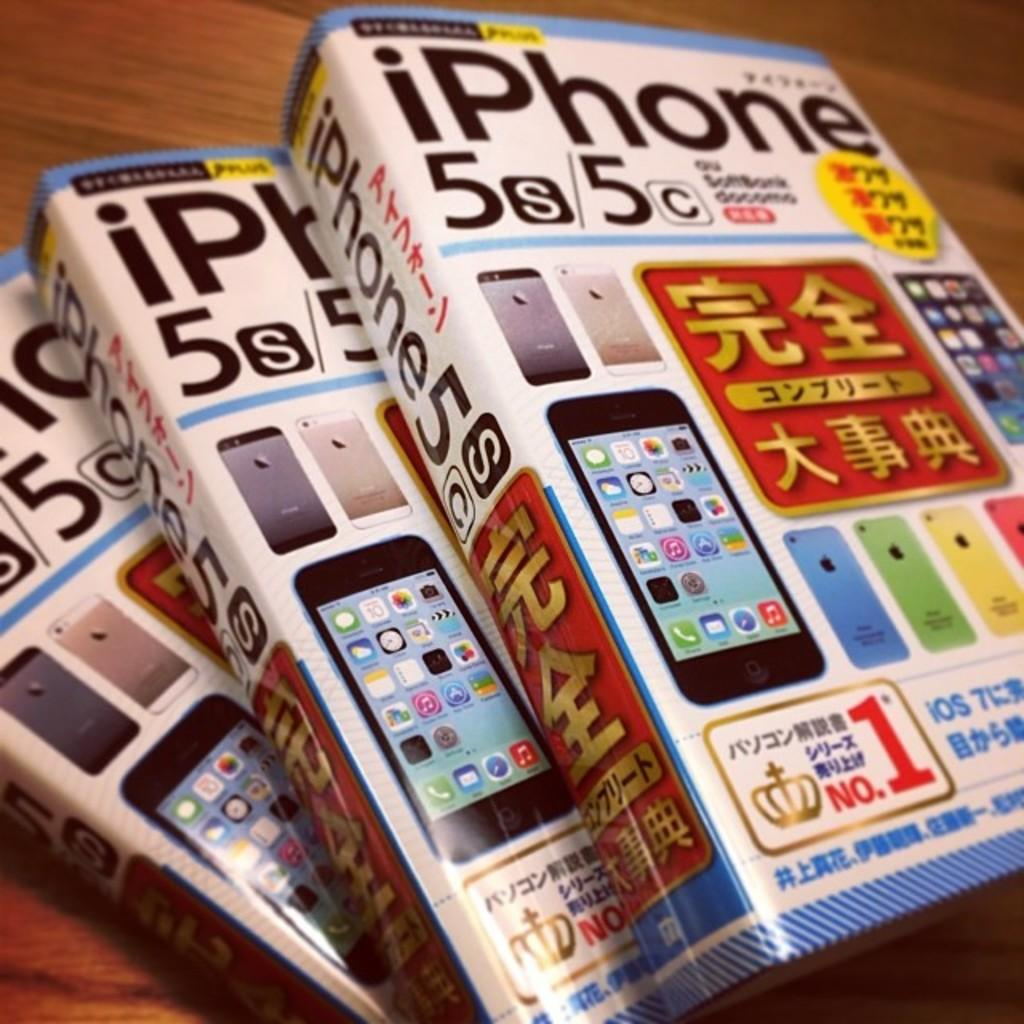What is the main object in the image? There is a table in the image. What is placed on the table? There are books on the table. What type of memory does the laborer have in the image? There is no laborer present in the image, and therefore no memory can be attributed to them. 